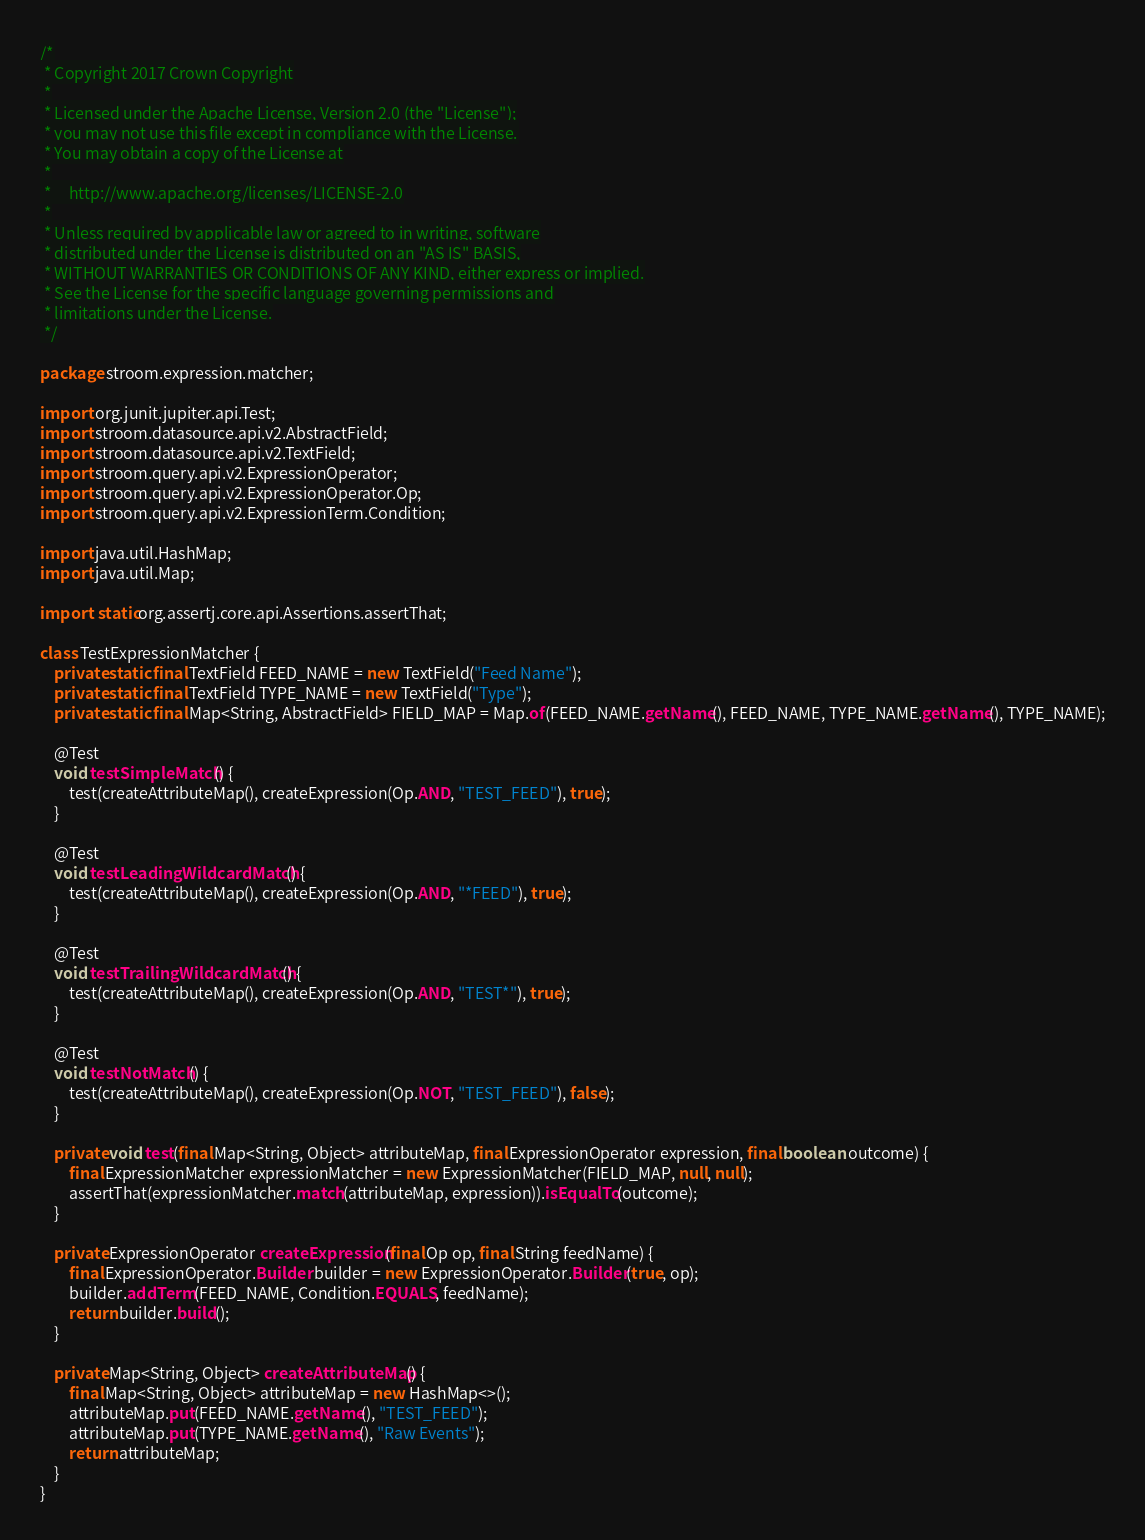Convert code to text. <code><loc_0><loc_0><loc_500><loc_500><_Java_>/*
 * Copyright 2017 Crown Copyright
 *
 * Licensed under the Apache License, Version 2.0 (the "License");
 * you may not use this file except in compliance with the License.
 * You may obtain a copy of the License at
 *
 *     http://www.apache.org/licenses/LICENSE-2.0
 *
 * Unless required by applicable law or agreed to in writing, software
 * distributed under the License is distributed on an "AS IS" BASIS,
 * WITHOUT WARRANTIES OR CONDITIONS OF ANY KIND, either express or implied.
 * See the License for the specific language governing permissions and
 * limitations under the License.
 */

package stroom.expression.matcher;

import org.junit.jupiter.api.Test;
import stroom.datasource.api.v2.AbstractField;
import stroom.datasource.api.v2.TextField;
import stroom.query.api.v2.ExpressionOperator;
import stroom.query.api.v2.ExpressionOperator.Op;
import stroom.query.api.v2.ExpressionTerm.Condition;

import java.util.HashMap;
import java.util.Map;

import static org.assertj.core.api.Assertions.assertThat;

class TestExpressionMatcher {
    private static final TextField FEED_NAME = new TextField("Feed Name");
    private static final TextField TYPE_NAME = new TextField("Type");
    private static final Map<String, AbstractField> FIELD_MAP = Map.of(FEED_NAME.getName(), FEED_NAME, TYPE_NAME.getName(), TYPE_NAME);

    @Test
    void testSimpleMatch() {
        test(createAttributeMap(), createExpression(Op.AND, "TEST_FEED"), true);
    }

    @Test
    void testLeadingWildcardMatch() {
        test(createAttributeMap(), createExpression(Op.AND, "*FEED"), true);
    }

    @Test
    void testTrailingWildcardMatch() {
        test(createAttributeMap(), createExpression(Op.AND, "TEST*"), true);
    }

    @Test
    void testNotMatch() {
        test(createAttributeMap(), createExpression(Op.NOT, "TEST_FEED"), false);
    }

    private void test(final Map<String, Object> attributeMap, final ExpressionOperator expression, final boolean outcome) {
        final ExpressionMatcher expressionMatcher = new ExpressionMatcher(FIELD_MAP, null, null);
        assertThat(expressionMatcher.match(attributeMap, expression)).isEqualTo(outcome);
    }

    private ExpressionOperator createExpression(final Op op, final String feedName) {
        final ExpressionOperator.Builder builder = new ExpressionOperator.Builder(true, op);
        builder.addTerm(FEED_NAME, Condition.EQUALS, feedName);
        return builder.build();
    }

    private Map<String, Object> createAttributeMap() {
        final Map<String, Object> attributeMap = new HashMap<>();
        attributeMap.put(FEED_NAME.getName(), "TEST_FEED");
        attributeMap.put(TYPE_NAME.getName(), "Raw Events");
        return attributeMap;
    }
}
</code> 